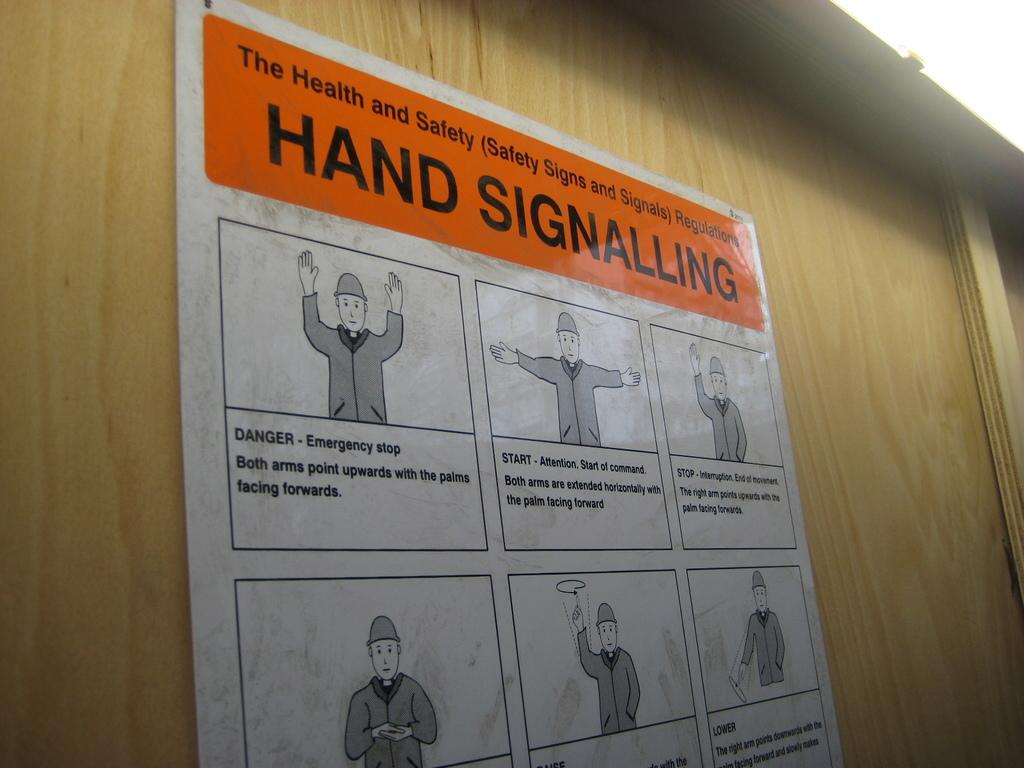<image>
Render a clear and concise summary of the photo. A health and safety public sign with images of hand signals on it. 